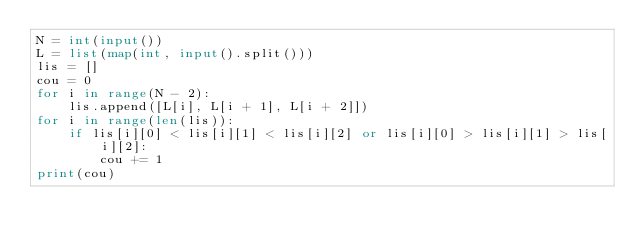<code> <loc_0><loc_0><loc_500><loc_500><_Python_>N = int(input())
L = list(map(int, input().split()))
lis = []
cou = 0
for i in range(N - 2):
    lis.append([L[i], L[i + 1], L[i + 2]])
for i in range(len(lis)):
    if lis[i][0] < lis[i][1] < lis[i][2] or lis[i][0] > lis[i][1] > lis[i][2]:
        cou += 1
print(cou)
</code> 